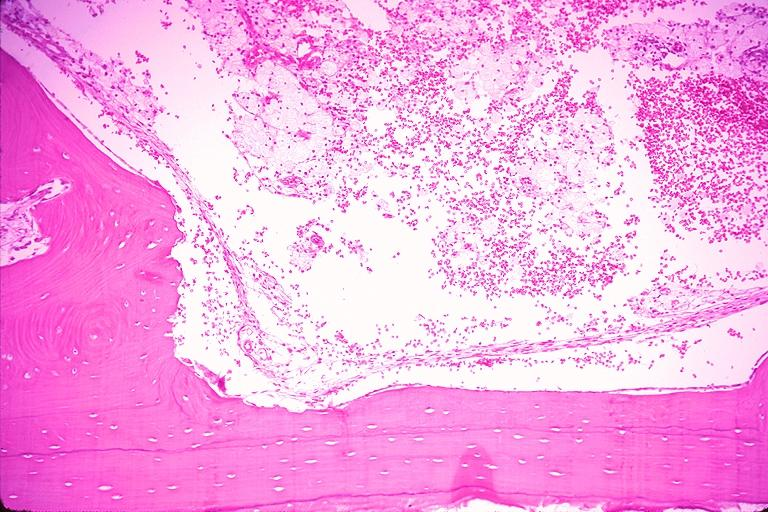what is present?
Answer the question using a single word or phrase. Oral 